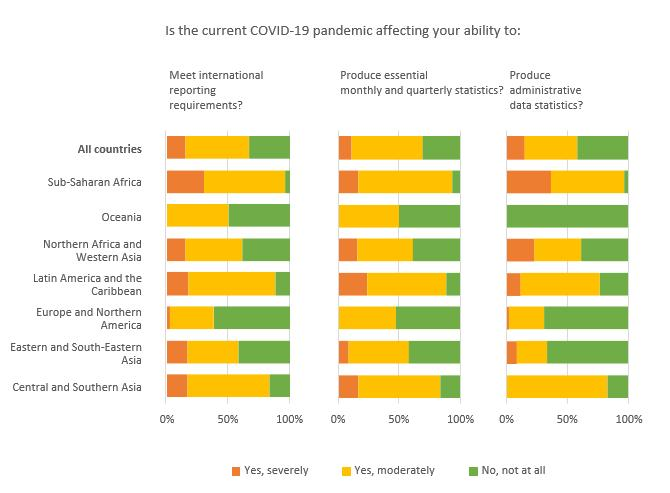Highlight a few significant elements in this photo. There is no evidence to suggest that COVID-19 is not having any impact on the ability to produce administrative data statistics in Oceania. Data indicates that the impact of Covid-19 on the ability to produce administrative data statistics in Central and Sub-Saharan Africa is not significant, with less than 50% of the data showing a negative impact. There is no data that suggests that COVID-19 has had a moderate impact on the ability to produce administrative data statistics in Oceania. A significant portion of available data indicates that COVID-19 is having a moderate impact on the ability of Oceania to produce essential monthly and quarterly statistics. There is no data available that indicates that Covid-19 is significantly affecting the ability to produce essential monthly and quarterly statistics for Oceania. 